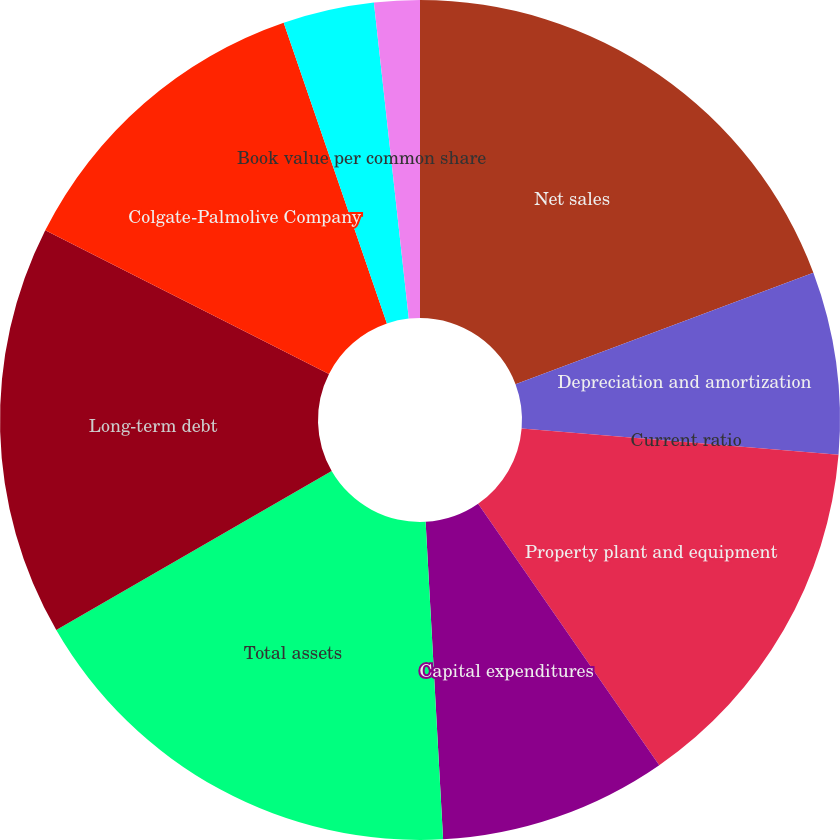<chart> <loc_0><loc_0><loc_500><loc_500><pie_chart><fcel>Net sales<fcel>Depreciation and amortization<fcel>Current ratio<fcel>Property plant and equipment<fcel>Capital expenditures<fcel>Total assets<fcel>Long-term debt<fcel>Colgate-Palmolive Company<fcel>Book value per common share<fcel>Cash dividends declared and<nl><fcel>19.3%<fcel>7.02%<fcel>0.0%<fcel>14.03%<fcel>8.77%<fcel>17.54%<fcel>15.79%<fcel>12.28%<fcel>3.51%<fcel>1.75%<nl></chart> 